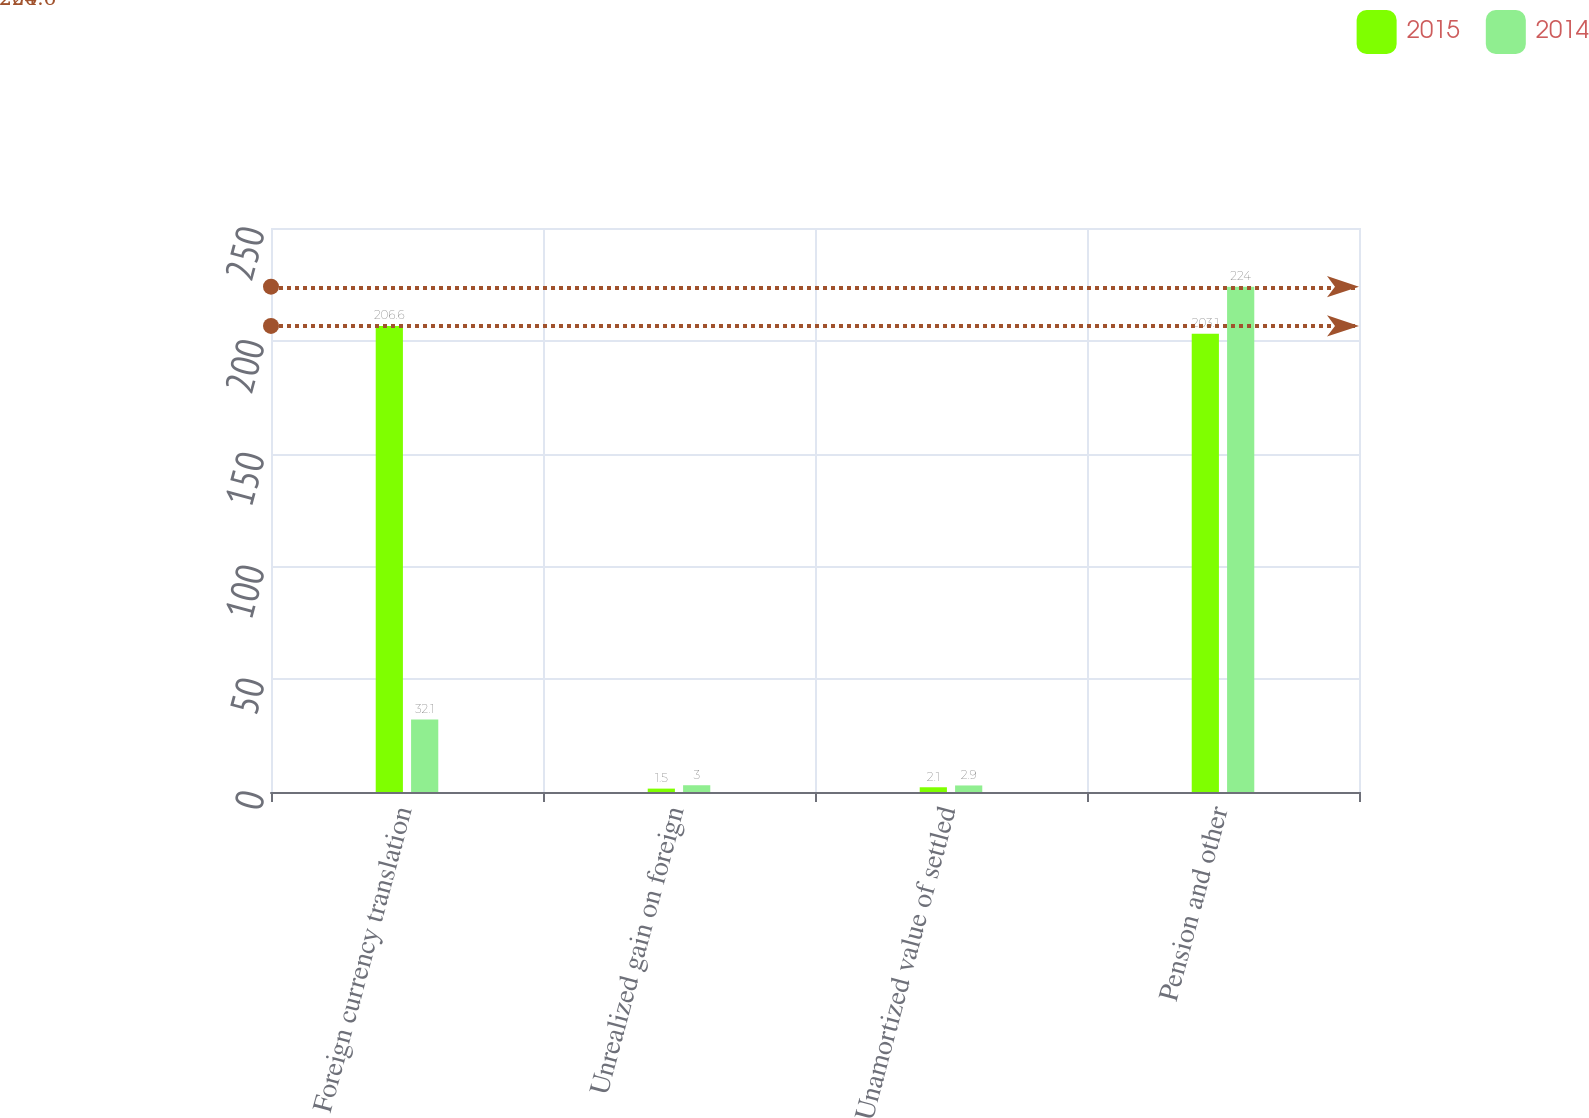<chart> <loc_0><loc_0><loc_500><loc_500><stacked_bar_chart><ecel><fcel>Foreign currency translation<fcel>Unrealized gain on foreign<fcel>Unamortized value of settled<fcel>Pension and other<nl><fcel>2015<fcel>206.6<fcel>1.5<fcel>2.1<fcel>203.1<nl><fcel>2014<fcel>32.1<fcel>3<fcel>2.9<fcel>224<nl></chart> 